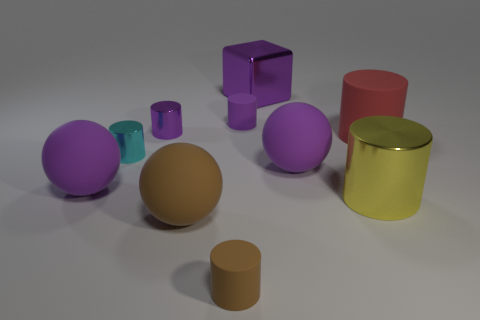What is the shape of the small rubber thing that is the same color as the metal block?
Your response must be concise. Cylinder. Is the number of big yellow metallic balls greater than the number of large cylinders?
Make the answer very short. No. What is the color of the small rubber thing behind the large object that is to the right of the big yellow metal object in front of the metallic cube?
Offer a terse response. Purple. There is a tiny matte object that is in front of the large metal cylinder; is its shape the same as the cyan metallic thing?
Give a very brief answer. Yes. What color is the metal object that is the same size as the block?
Your response must be concise. Yellow. What number of large cyan metallic objects are there?
Offer a very short reply. 0. Do the large object that is left of the small purple metallic thing and the cyan object have the same material?
Give a very brief answer. No. What material is the big thing that is behind the cyan metal object and to the right of the big cube?
Provide a short and direct response. Rubber. The tiny brown thing that is in front of the purple rubber object that is on the left side of the tiny purple rubber object is made of what material?
Your answer should be very brief. Rubber. There is a cyan object that is on the right side of the purple matte thing in front of the purple sphere that is right of the purple block; what size is it?
Your response must be concise. Small. 